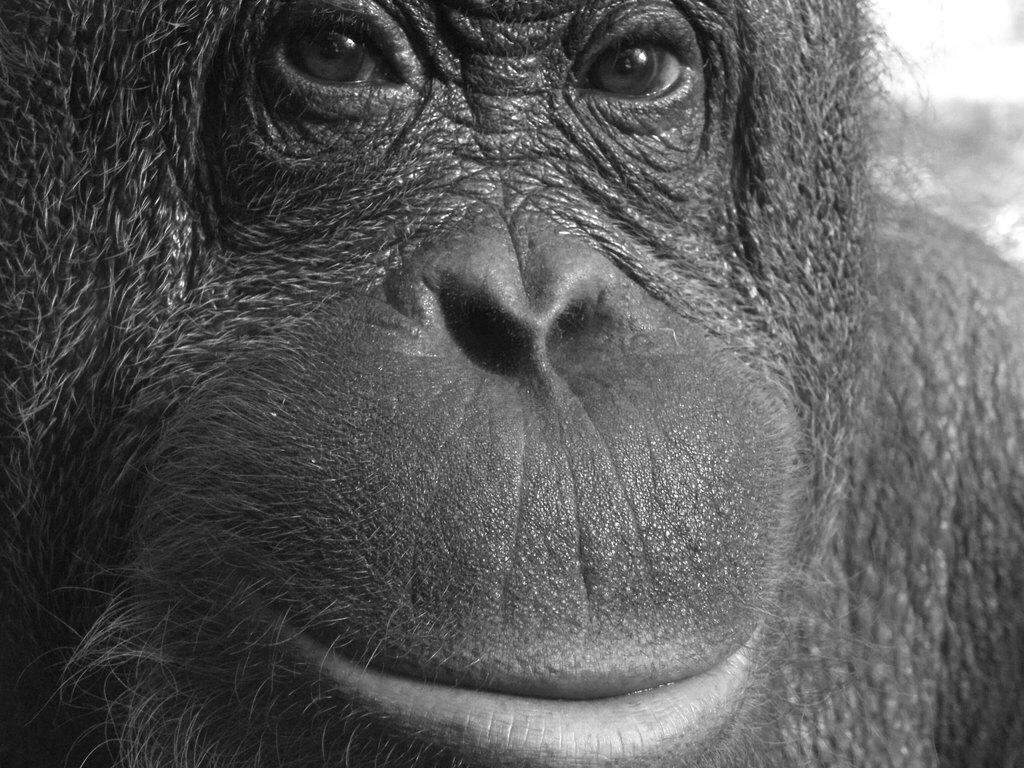What type of animal is in the image? There is a gorilla in the image. How many sheep are visible in the image? There are no sheep present in the image; it features a gorilla. Are there any dinosaurs visible in the image? There are no dinosaurs present in the image; it features a gorilla. 